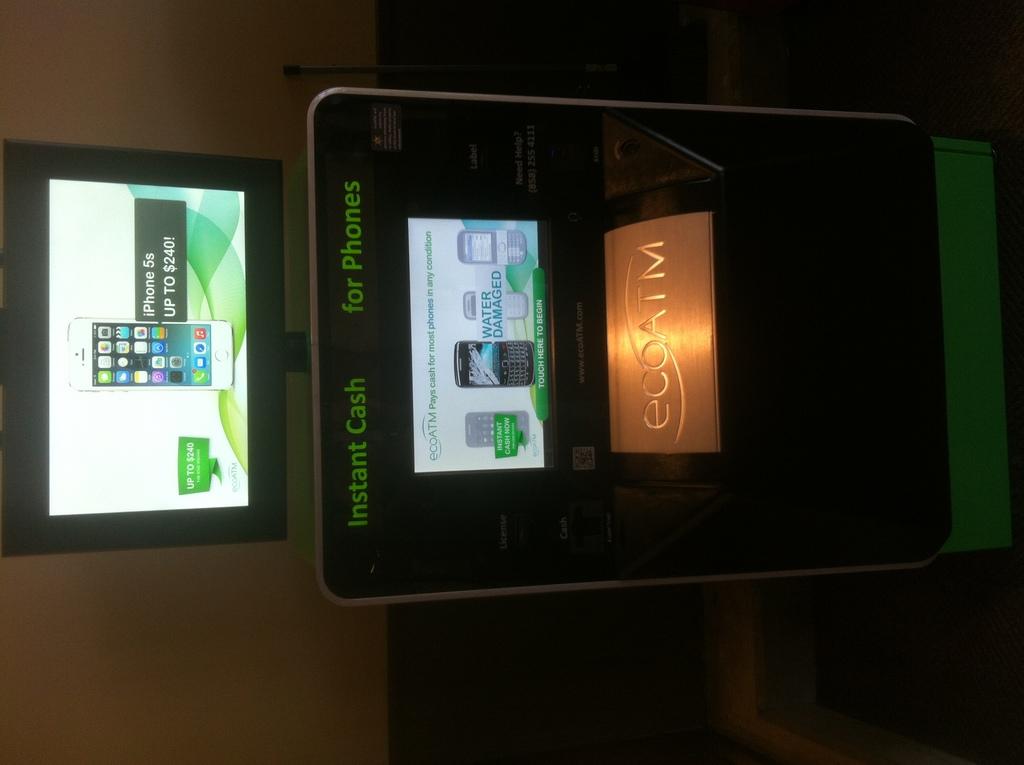What will the machine give you cash for?
Give a very brief answer. Phones. What does this machine give you for iphones?
Your answer should be very brief. Instant cash. 